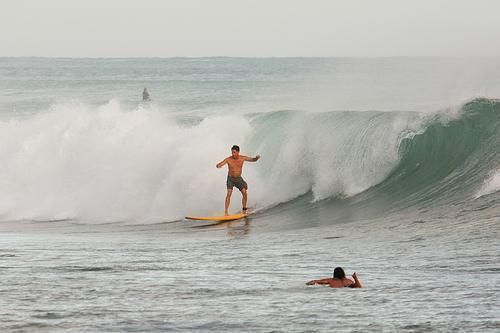How many people are in the picture?
Give a very brief answer. 3. 